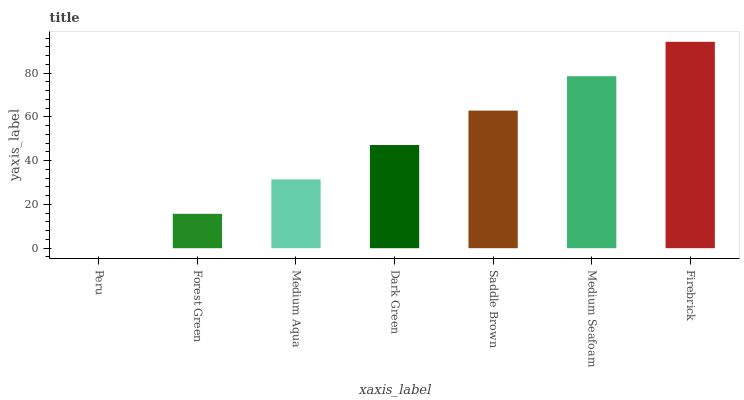Is Forest Green the minimum?
Answer yes or no. No. Is Forest Green the maximum?
Answer yes or no. No. Is Forest Green greater than Peru?
Answer yes or no. Yes. Is Peru less than Forest Green?
Answer yes or no. Yes. Is Peru greater than Forest Green?
Answer yes or no. No. Is Forest Green less than Peru?
Answer yes or no. No. Is Dark Green the high median?
Answer yes or no. Yes. Is Dark Green the low median?
Answer yes or no. Yes. Is Medium Aqua the high median?
Answer yes or no. No. Is Medium Seafoam the low median?
Answer yes or no. No. 